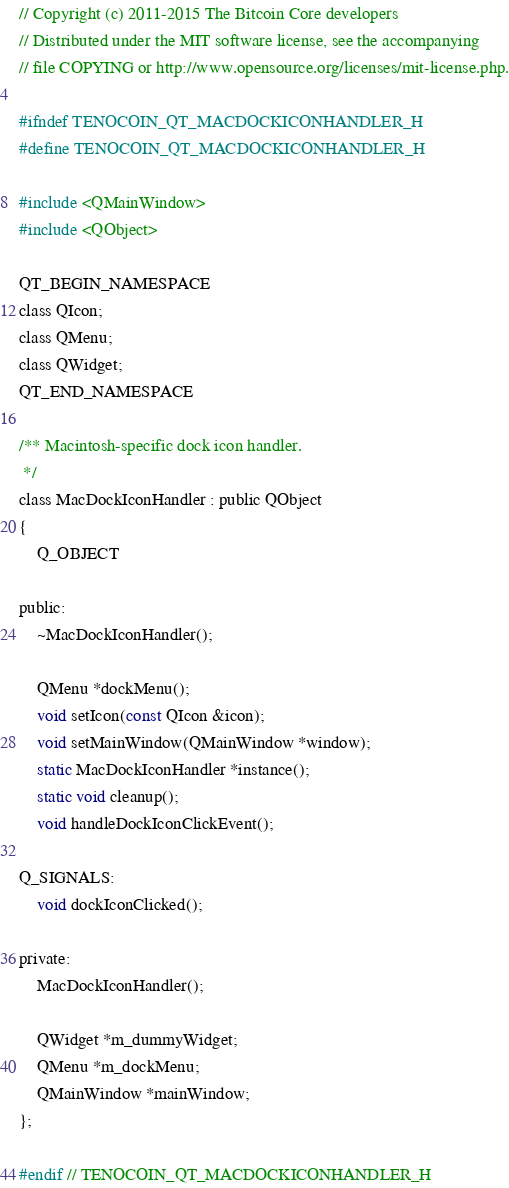Convert code to text. <code><loc_0><loc_0><loc_500><loc_500><_C_>// Copyright (c) 2011-2015 The Bitcoin Core developers
// Distributed under the MIT software license, see the accompanying
// file COPYING or http://www.opensource.org/licenses/mit-license.php.

#ifndef TENOCOIN_QT_MACDOCKICONHANDLER_H
#define TENOCOIN_QT_MACDOCKICONHANDLER_H

#include <QMainWindow>
#include <QObject>

QT_BEGIN_NAMESPACE
class QIcon;
class QMenu;
class QWidget;
QT_END_NAMESPACE

/** Macintosh-specific dock icon handler.
 */
class MacDockIconHandler : public QObject
{
    Q_OBJECT

public:
    ~MacDockIconHandler();

    QMenu *dockMenu();
    void setIcon(const QIcon &icon);
    void setMainWindow(QMainWindow *window);
    static MacDockIconHandler *instance();
    static void cleanup();
    void handleDockIconClickEvent();

Q_SIGNALS:
    void dockIconClicked();

private:
    MacDockIconHandler();

    QWidget *m_dummyWidget;
    QMenu *m_dockMenu;
    QMainWindow *mainWindow;
};

#endif // TENOCOIN_QT_MACDOCKICONHANDLER_H
</code> 